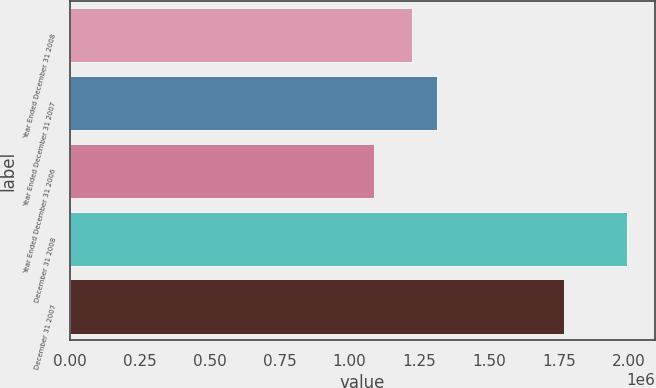<chart> <loc_0><loc_0><loc_500><loc_500><bar_chart><fcel>Year Ended December 31 2008<fcel>Year Ended December 31 2007<fcel>Year Ended December 31 2006<fcel>December 31 2008<fcel>December 31 2007<nl><fcel>1.22258e+06<fcel>1.31313e+06<fcel>1.08778e+06<fcel>1.99331e+06<fcel>1.76692e+06<nl></chart> 